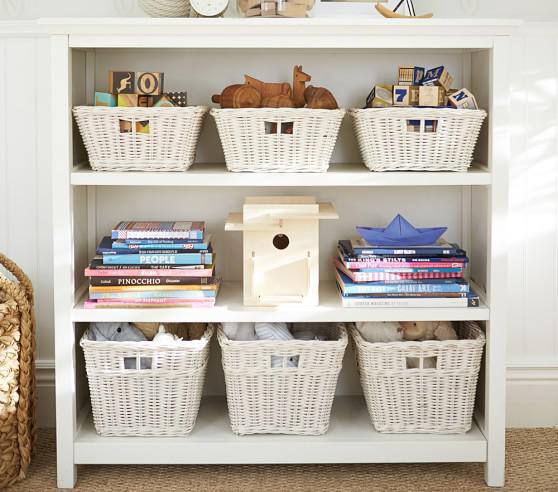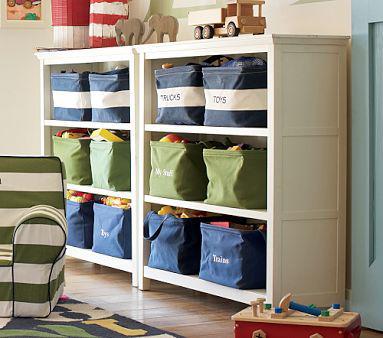The first image is the image on the left, the second image is the image on the right. Assess this claim about the two images: "Two shelf units, one on short legs and one flush with the floor, are different widths and have a different number of shelves.". Correct or not? Answer yes or no. No. The first image is the image on the left, the second image is the image on the right. For the images displayed, is the sentence "One storage unit contains some blue bins with labels on the front, and the other holds several fiber-type baskets." factually correct? Answer yes or no. Yes. 